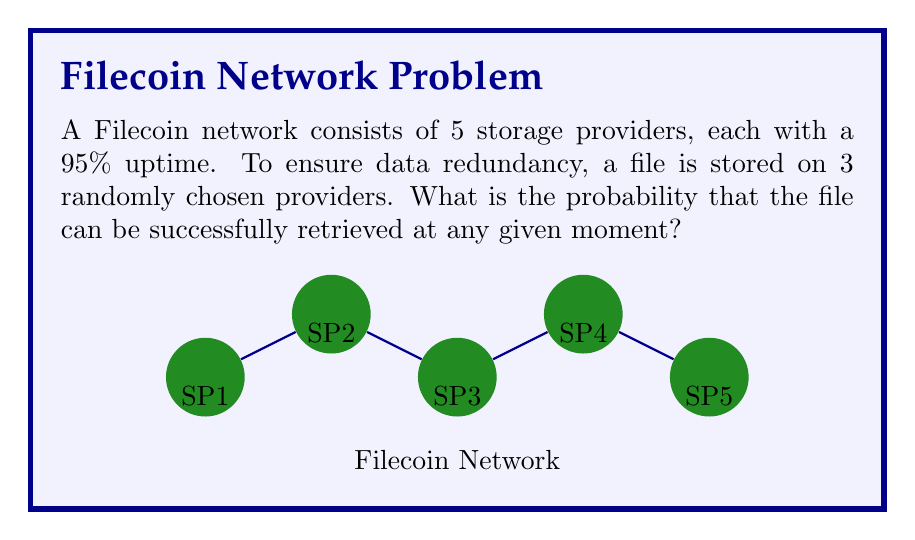Show me your answer to this math problem. Let's approach this step-by-step:

1) First, we need to calculate the probability of a file being unavailable from a single provider:
   $P(\text{unavailable}) = 1 - 0.95 = 0.05$

2) For the file to be irretrievable, all 3 providers storing it must be unavailable simultaneously. The probability of this happening is:
   $P(\text{all 3 unavailable}) = 0.05^3 = 0.000125$

3) Therefore, the probability of being able to retrieve the file is the complement of this:
   $P(\text{retrievable}) = 1 - P(\text{all 3 unavailable}) = 1 - 0.000125 = 0.999875$

4) We can also express this using the probability of at least one provider being available:
   $P(\text{retrievable}) = 1 - (1-0.95)^3 = 1 - 0.05^3 = 0.999875$

5) To convert to a percentage:
   $0.999875 \times 100\% = 99.9875\%$

This high probability demonstrates the effectiveness of the redundancy strategy in the Filecoin network.
Answer: $99.9875\%$ 